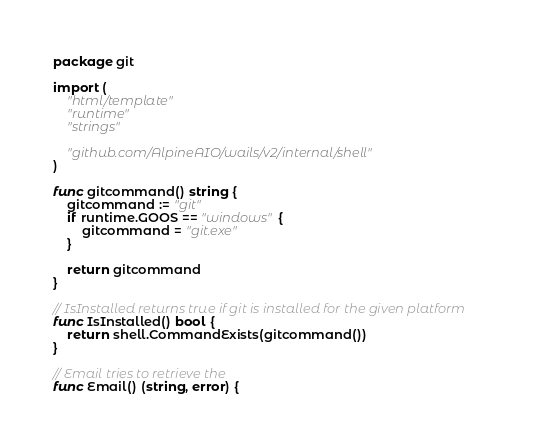Convert code to text. <code><loc_0><loc_0><loc_500><loc_500><_Go_>package git

import (
	"html/template"
	"runtime"
	"strings"

	"github.com/AlpineAIO/wails/v2/internal/shell"
)

func gitcommand() string {
	gitcommand := "git"
	if runtime.GOOS == "windows" {
		gitcommand = "git.exe"
	}

	return gitcommand
}

// IsInstalled returns true if git is installed for the given platform
func IsInstalled() bool {
	return shell.CommandExists(gitcommand())
}

// Email tries to retrieve the
func Email() (string, error) {</code> 